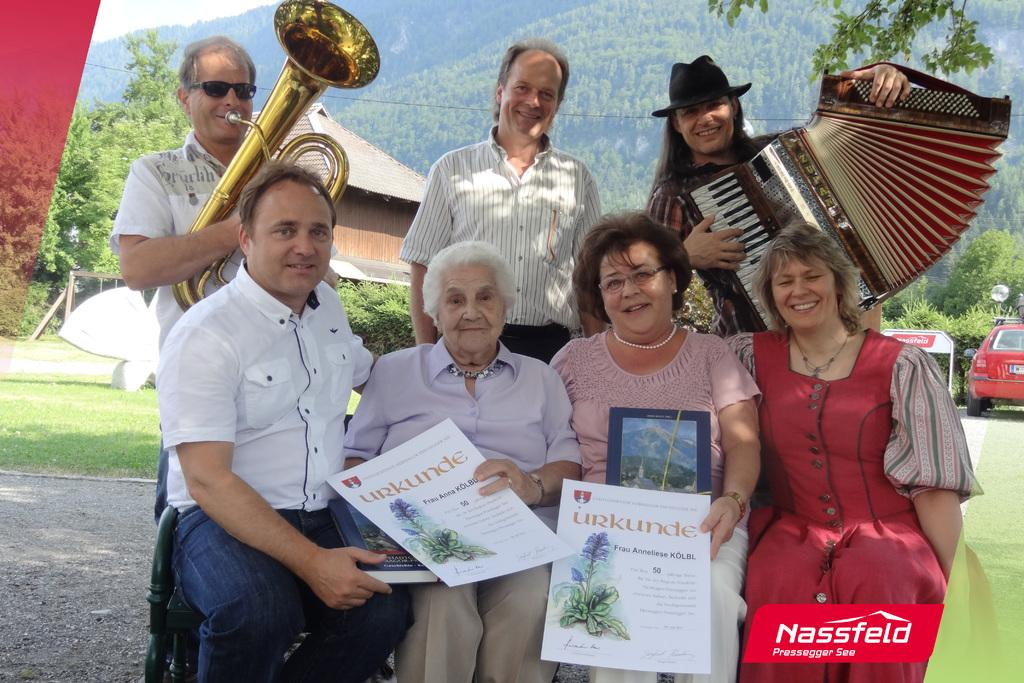Provide a one-sentence caption for the provided image. A family, some of whom are playing instruments, are displayed with the brand Nassfel in the corner. 